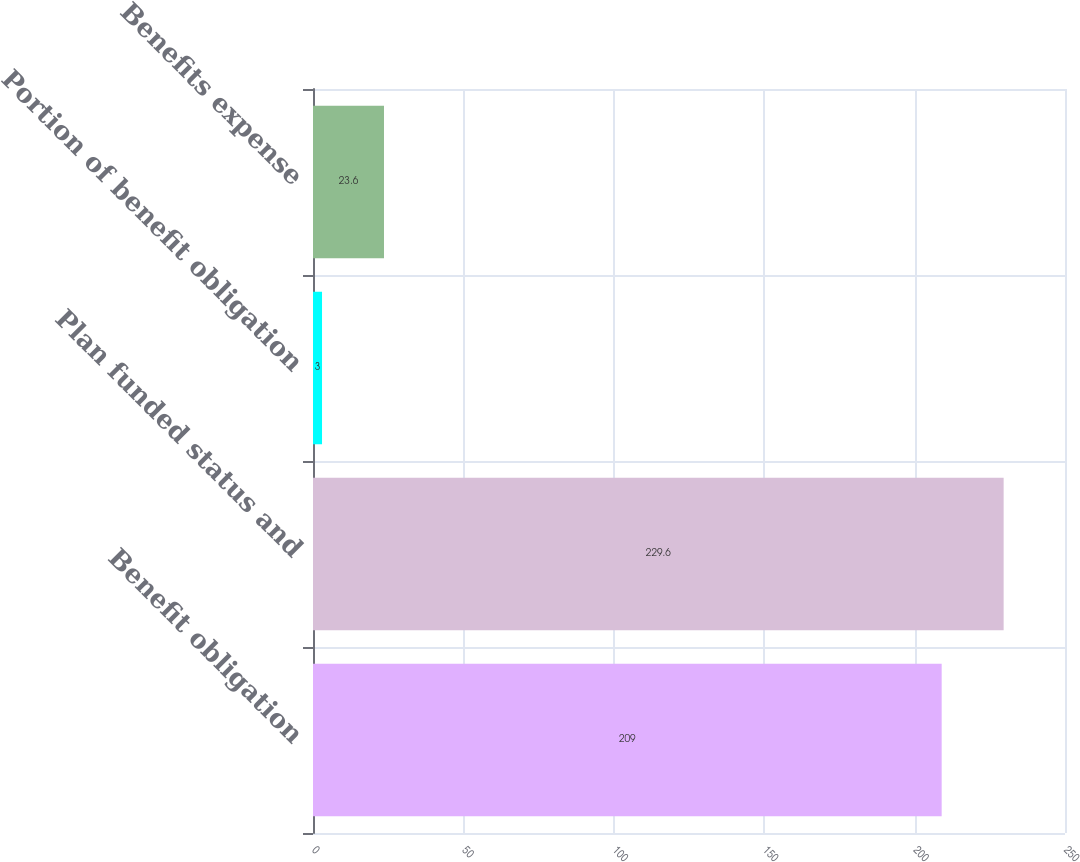<chart> <loc_0><loc_0><loc_500><loc_500><bar_chart><fcel>Benefit obligation<fcel>Plan funded status and<fcel>Portion of benefit obligation<fcel>Benefits expense<nl><fcel>209<fcel>229.6<fcel>3<fcel>23.6<nl></chart> 